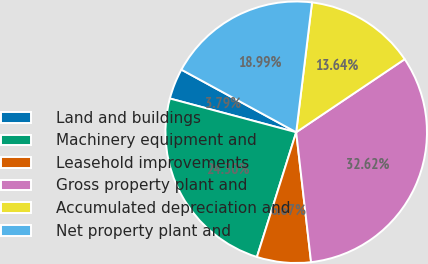Convert chart to OTSL. <chart><loc_0><loc_0><loc_500><loc_500><pie_chart><fcel>Land and buildings<fcel>Machinery equipment and<fcel>Leasehold improvements<fcel>Gross property plant and<fcel>Accumulated depreciation and<fcel>Net property plant and<nl><fcel>3.79%<fcel>24.3%<fcel>6.67%<fcel>32.62%<fcel>13.64%<fcel>18.99%<nl></chart> 